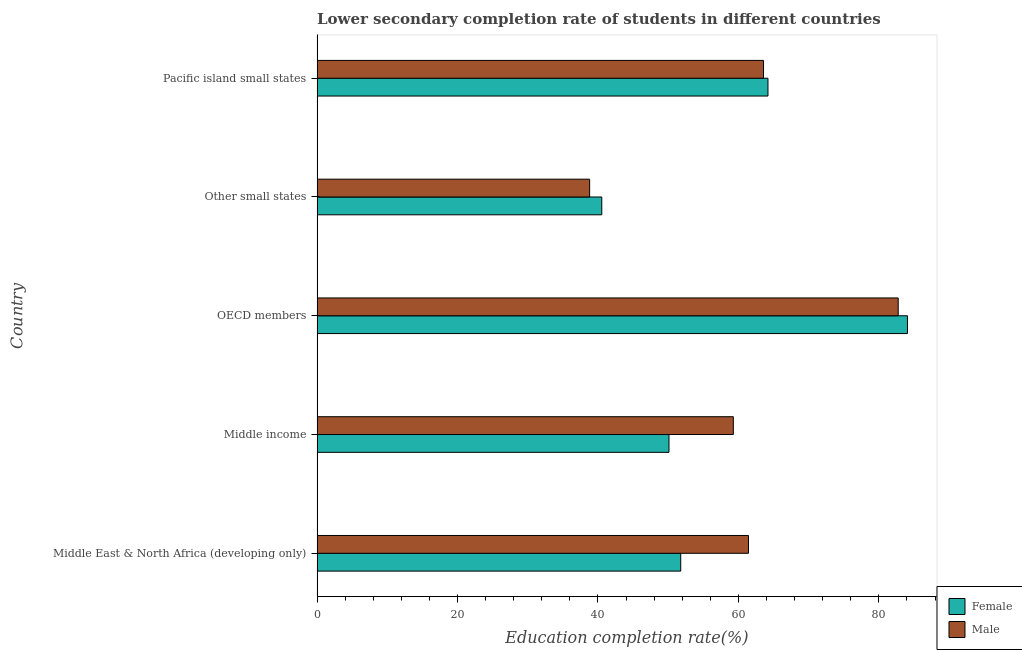How many groups of bars are there?
Your answer should be very brief. 5. Are the number of bars per tick equal to the number of legend labels?
Keep it short and to the point. Yes. How many bars are there on the 3rd tick from the bottom?
Make the answer very short. 2. What is the label of the 5th group of bars from the top?
Ensure brevity in your answer.  Middle East & North Africa (developing only). What is the education completion rate of male students in Middle income?
Your response must be concise. 59.27. Across all countries, what is the maximum education completion rate of female students?
Your response must be concise. 84.07. Across all countries, what is the minimum education completion rate of male students?
Make the answer very short. 38.81. In which country was the education completion rate of male students maximum?
Your response must be concise. OECD members. In which country was the education completion rate of female students minimum?
Your answer should be compact. Other small states. What is the total education completion rate of female students in the graph?
Make the answer very short. 290.71. What is the difference between the education completion rate of female students in Other small states and that in Pacific island small states?
Your response must be concise. -23.66. What is the difference between the education completion rate of female students in Pacific island small states and the education completion rate of male students in OECD members?
Ensure brevity in your answer.  -18.54. What is the average education completion rate of female students per country?
Make the answer very short. 58.14. What is the difference between the education completion rate of male students and education completion rate of female students in Pacific island small states?
Offer a very short reply. -0.63. In how many countries, is the education completion rate of male students greater than 4 %?
Keep it short and to the point. 5. What is the ratio of the education completion rate of male students in Middle income to that in Other small states?
Offer a terse response. 1.53. Is the education completion rate of male students in OECD members less than that in Pacific island small states?
Your response must be concise. No. What is the difference between the highest and the second highest education completion rate of female students?
Offer a terse response. 19.86. What is the difference between the highest and the lowest education completion rate of male students?
Offer a very short reply. 43.93. In how many countries, is the education completion rate of female students greater than the average education completion rate of female students taken over all countries?
Offer a very short reply. 2. Is the sum of the education completion rate of male students in OECD members and Pacific island small states greater than the maximum education completion rate of female students across all countries?
Your answer should be compact. Yes. What does the 2nd bar from the top in Middle income represents?
Offer a very short reply. Female. What does the 1st bar from the bottom in Pacific island small states represents?
Ensure brevity in your answer.  Female. Are all the bars in the graph horizontal?
Keep it short and to the point. Yes. How many countries are there in the graph?
Your response must be concise. 5. Where does the legend appear in the graph?
Provide a short and direct response. Bottom right. What is the title of the graph?
Provide a short and direct response. Lower secondary completion rate of students in different countries. Does "Boys" appear as one of the legend labels in the graph?
Keep it short and to the point. No. What is the label or title of the X-axis?
Offer a very short reply. Education completion rate(%). What is the label or title of the Y-axis?
Provide a short and direct response. Country. What is the Education completion rate(%) in Female in Middle East & North Africa (developing only)?
Make the answer very short. 51.78. What is the Education completion rate(%) in Male in Middle East & North Africa (developing only)?
Your answer should be very brief. 61.43. What is the Education completion rate(%) in Female in Middle income?
Offer a terse response. 50.11. What is the Education completion rate(%) of Male in Middle income?
Make the answer very short. 59.27. What is the Education completion rate(%) in Female in OECD members?
Provide a succinct answer. 84.07. What is the Education completion rate(%) of Male in OECD members?
Keep it short and to the point. 82.75. What is the Education completion rate(%) in Female in Other small states?
Keep it short and to the point. 40.54. What is the Education completion rate(%) in Male in Other small states?
Give a very brief answer. 38.81. What is the Education completion rate(%) in Female in Pacific island small states?
Provide a short and direct response. 64.21. What is the Education completion rate(%) of Male in Pacific island small states?
Make the answer very short. 63.57. Across all countries, what is the maximum Education completion rate(%) in Female?
Your answer should be compact. 84.07. Across all countries, what is the maximum Education completion rate(%) of Male?
Give a very brief answer. 82.75. Across all countries, what is the minimum Education completion rate(%) in Female?
Make the answer very short. 40.54. Across all countries, what is the minimum Education completion rate(%) of Male?
Make the answer very short. 38.81. What is the total Education completion rate(%) of Female in the graph?
Your response must be concise. 290.71. What is the total Education completion rate(%) in Male in the graph?
Give a very brief answer. 305.84. What is the difference between the Education completion rate(%) in Female in Middle East & North Africa (developing only) and that in Middle income?
Your answer should be compact. 1.67. What is the difference between the Education completion rate(%) of Male in Middle East & North Africa (developing only) and that in Middle income?
Offer a terse response. 2.16. What is the difference between the Education completion rate(%) in Female in Middle East & North Africa (developing only) and that in OECD members?
Your answer should be very brief. -32.28. What is the difference between the Education completion rate(%) of Male in Middle East & North Africa (developing only) and that in OECD members?
Make the answer very short. -21.32. What is the difference between the Education completion rate(%) in Female in Middle East & North Africa (developing only) and that in Other small states?
Provide a short and direct response. 11.24. What is the difference between the Education completion rate(%) of Male in Middle East & North Africa (developing only) and that in Other small states?
Your answer should be compact. 22.61. What is the difference between the Education completion rate(%) in Female in Middle East & North Africa (developing only) and that in Pacific island small states?
Provide a succinct answer. -12.42. What is the difference between the Education completion rate(%) of Male in Middle East & North Africa (developing only) and that in Pacific island small states?
Keep it short and to the point. -2.14. What is the difference between the Education completion rate(%) of Female in Middle income and that in OECD members?
Offer a terse response. -33.96. What is the difference between the Education completion rate(%) in Male in Middle income and that in OECD members?
Provide a succinct answer. -23.48. What is the difference between the Education completion rate(%) in Female in Middle income and that in Other small states?
Provide a succinct answer. 9.57. What is the difference between the Education completion rate(%) in Male in Middle income and that in Other small states?
Your answer should be very brief. 20.46. What is the difference between the Education completion rate(%) in Female in Middle income and that in Pacific island small states?
Keep it short and to the point. -14.09. What is the difference between the Education completion rate(%) in Male in Middle income and that in Pacific island small states?
Keep it short and to the point. -4.3. What is the difference between the Education completion rate(%) of Female in OECD members and that in Other small states?
Make the answer very short. 43.53. What is the difference between the Education completion rate(%) of Male in OECD members and that in Other small states?
Offer a terse response. 43.93. What is the difference between the Education completion rate(%) of Female in OECD members and that in Pacific island small states?
Your answer should be compact. 19.86. What is the difference between the Education completion rate(%) in Male in OECD members and that in Pacific island small states?
Provide a succinct answer. 19.18. What is the difference between the Education completion rate(%) in Female in Other small states and that in Pacific island small states?
Ensure brevity in your answer.  -23.66. What is the difference between the Education completion rate(%) in Male in Other small states and that in Pacific island small states?
Your answer should be very brief. -24.76. What is the difference between the Education completion rate(%) of Female in Middle East & North Africa (developing only) and the Education completion rate(%) of Male in Middle income?
Ensure brevity in your answer.  -7.49. What is the difference between the Education completion rate(%) of Female in Middle East & North Africa (developing only) and the Education completion rate(%) of Male in OECD members?
Offer a very short reply. -30.96. What is the difference between the Education completion rate(%) of Female in Middle East & North Africa (developing only) and the Education completion rate(%) of Male in Other small states?
Provide a succinct answer. 12.97. What is the difference between the Education completion rate(%) of Female in Middle East & North Africa (developing only) and the Education completion rate(%) of Male in Pacific island small states?
Offer a very short reply. -11.79. What is the difference between the Education completion rate(%) in Female in Middle income and the Education completion rate(%) in Male in OECD members?
Provide a short and direct response. -32.64. What is the difference between the Education completion rate(%) of Female in Middle income and the Education completion rate(%) of Male in Other small states?
Offer a terse response. 11.3. What is the difference between the Education completion rate(%) in Female in Middle income and the Education completion rate(%) in Male in Pacific island small states?
Keep it short and to the point. -13.46. What is the difference between the Education completion rate(%) in Female in OECD members and the Education completion rate(%) in Male in Other small states?
Your answer should be compact. 45.25. What is the difference between the Education completion rate(%) in Female in OECD members and the Education completion rate(%) in Male in Pacific island small states?
Give a very brief answer. 20.5. What is the difference between the Education completion rate(%) of Female in Other small states and the Education completion rate(%) of Male in Pacific island small states?
Offer a very short reply. -23.03. What is the average Education completion rate(%) of Female per country?
Ensure brevity in your answer.  58.14. What is the average Education completion rate(%) in Male per country?
Offer a terse response. 61.17. What is the difference between the Education completion rate(%) of Female and Education completion rate(%) of Male in Middle East & North Africa (developing only)?
Make the answer very short. -9.64. What is the difference between the Education completion rate(%) in Female and Education completion rate(%) in Male in Middle income?
Your response must be concise. -9.16. What is the difference between the Education completion rate(%) of Female and Education completion rate(%) of Male in OECD members?
Offer a terse response. 1.32. What is the difference between the Education completion rate(%) of Female and Education completion rate(%) of Male in Other small states?
Your response must be concise. 1.73. What is the difference between the Education completion rate(%) of Female and Education completion rate(%) of Male in Pacific island small states?
Provide a short and direct response. 0.63. What is the ratio of the Education completion rate(%) in Female in Middle East & North Africa (developing only) to that in Middle income?
Offer a very short reply. 1.03. What is the ratio of the Education completion rate(%) of Male in Middle East & North Africa (developing only) to that in Middle income?
Provide a succinct answer. 1.04. What is the ratio of the Education completion rate(%) in Female in Middle East & North Africa (developing only) to that in OECD members?
Your response must be concise. 0.62. What is the ratio of the Education completion rate(%) of Male in Middle East & North Africa (developing only) to that in OECD members?
Keep it short and to the point. 0.74. What is the ratio of the Education completion rate(%) of Female in Middle East & North Africa (developing only) to that in Other small states?
Provide a short and direct response. 1.28. What is the ratio of the Education completion rate(%) of Male in Middle East & North Africa (developing only) to that in Other small states?
Offer a terse response. 1.58. What is the ratio of the Education completion rate(%) in Female in Middle East & North Africa (developing only) to that in Pacific island small states?
Your answer should be very brief. 0.81. What is the ratio of the Education completion rate(%) in Male in Middle East & North Africa (developing only) to that in Pacific island small states?
Keep it short and to the point. 0.97. What is the ratio of the Education completion rate(%) in Female in Middle income to that in OECD members?
Your answer should be very brief. 0.6. What is the ratio of the Education completion rate(%) in Male in Middle income to that in OECD members?
Your answer should be very brief. 0.72. What is the ratio of the Education completion rate(%) of Female in Middle income to that in Other small states?
Ensure brevity in your answer.  1.24. What is the ratio of the Education completion rate(%) in Male in Middle income to that in Other small states?
Give a very brief answer. 1.53. What is the ratio of the Education completion rate(%) in Female in Middle income to that in Pacific island small states?
Provide a short and direct response. 0.78. What is the ratio of the Education completion rate(%) in Male in Middle income to that in Pacific island small states?
Your response must be concise. 0.93. What is the ratio of the Education completion rate(%) of Female in OECD members to that in Other small states?
Your answer should be very brief. 2.07. What is the ratio of the Education completion rate(%) in Male in OECD members to that in Other small states?
Give a very brief answer. 2.13. What is the ratio of the Education completion rate(%) of Female in OECD members to that in Pacific island small states?
Your response must be concise. 1.31. What is the ratio of the Education completion rate(%) of Male in OECD members to that in Pacific island small states?
Give a very brief answer. 1.3. What is the ratio of the Education completion rate(%) of Female in Other small states to that in Pacific island small states?
Provide a succinct answer. 0.63. What is the ratio of the Education completion rate(%) in Male in Other small states to that in Pacific island small states?
Provide a short and direct response. 0.61. What is the difference between the highest and the second highest Education completion rate(%) of Female?
Make the answer very short. 19.86. What is the difference between the highest and the second highest Education completion rate(%) of Male?
Make the answer very short. 19.18. What is the difference between the highest and the lowest Education completion rate(%) of Female?
Make the answer very short. 43.53. What is the difference between the highest and the lowest Education completion rate(%) in Male?
Provide a succinct answer. 43.93. 